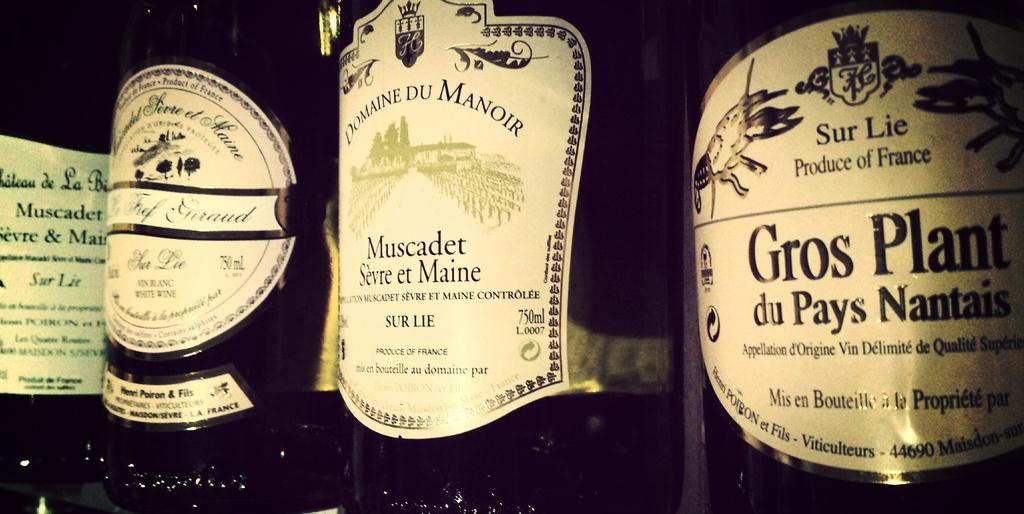How many millilitres are in muscadet sevre et maine?
Offer a terse response. 750. 